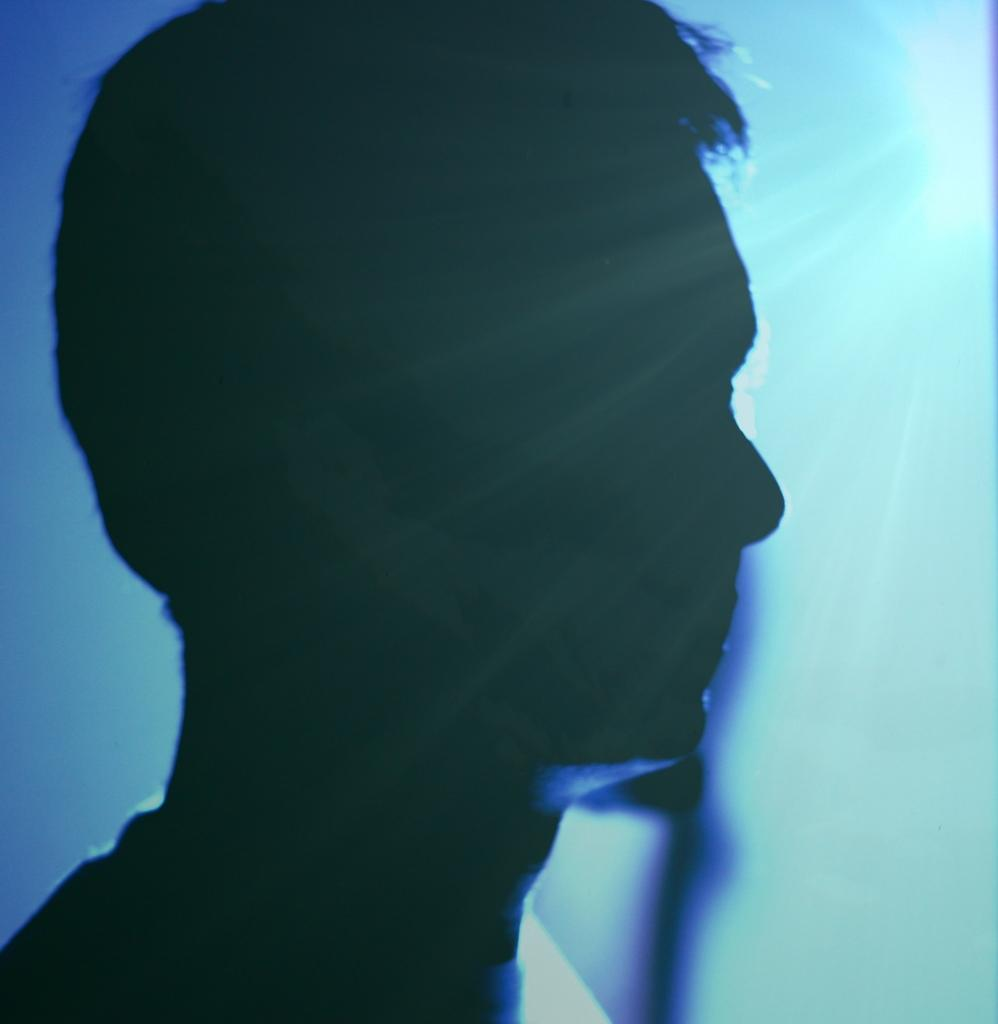What is the main subject of the image? There is a person in the image. What color is the background of the image? The background of the image is blue. How many metal girls are present in the image? There are no metal girls present in the image, as the facts provided do not mention any metal or girls. 